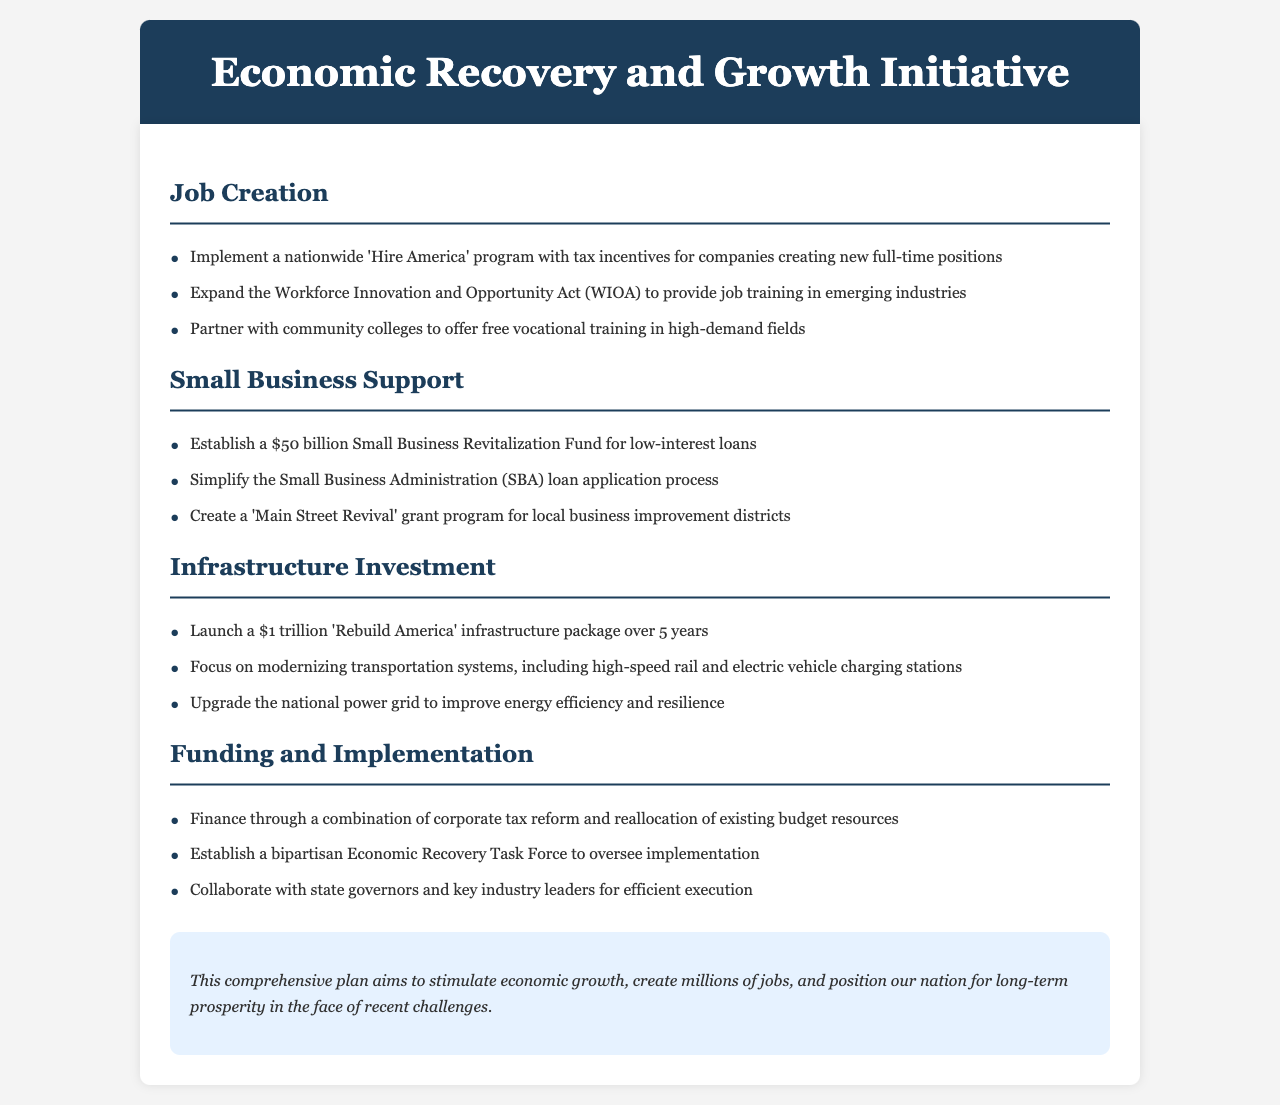What is the name of the program intended to increase job creation? The program is designed to create new full-time positions by providing tax incentives to companies.
Answer: Hire America How much funding is allocated for the Small Business Revitalization Fund? This fund aims to support small businesses with low-interest loans amounting to a specific financial commitment.
Answer: $50 billion What is the total monetary value of the 'Rebuild America' infrastructure package? The document specifies a set amount for infrastructure investment to modernize the nation's infrastructure over a specified period.
Answer: $1 trillion Which act is expanded to provide job training in emerging industries? This act is targeted toward improving workforce development and job preparedness across various sectors.
Answer: Workforce Innovation and Opportunity Act (WIOA) What is one of the main focuses of the infrastructure investment? The document outlines the intention to modernize vital transportation frameworks and energy systems as part of the initiative.
Answer: High-speed rail Who will oversee the implementation of the funding and initiatives outlined in the document? The document states that a particular group, known for its bipartisan nature, will be responsible for supervision and execution.
Answer: Economic Recovery Task Force What type of training is offered through partnerships with community colleges? The initiative aims to support vocational education and skill-building in various fields through educational collaborations.
Answer: Free vocational training What will be simplified to support small businesses? The document mentions the aim of making a commonly used financial support process easier and more accessible for businesses seeking assistance.
Answer: SBA loan application process 